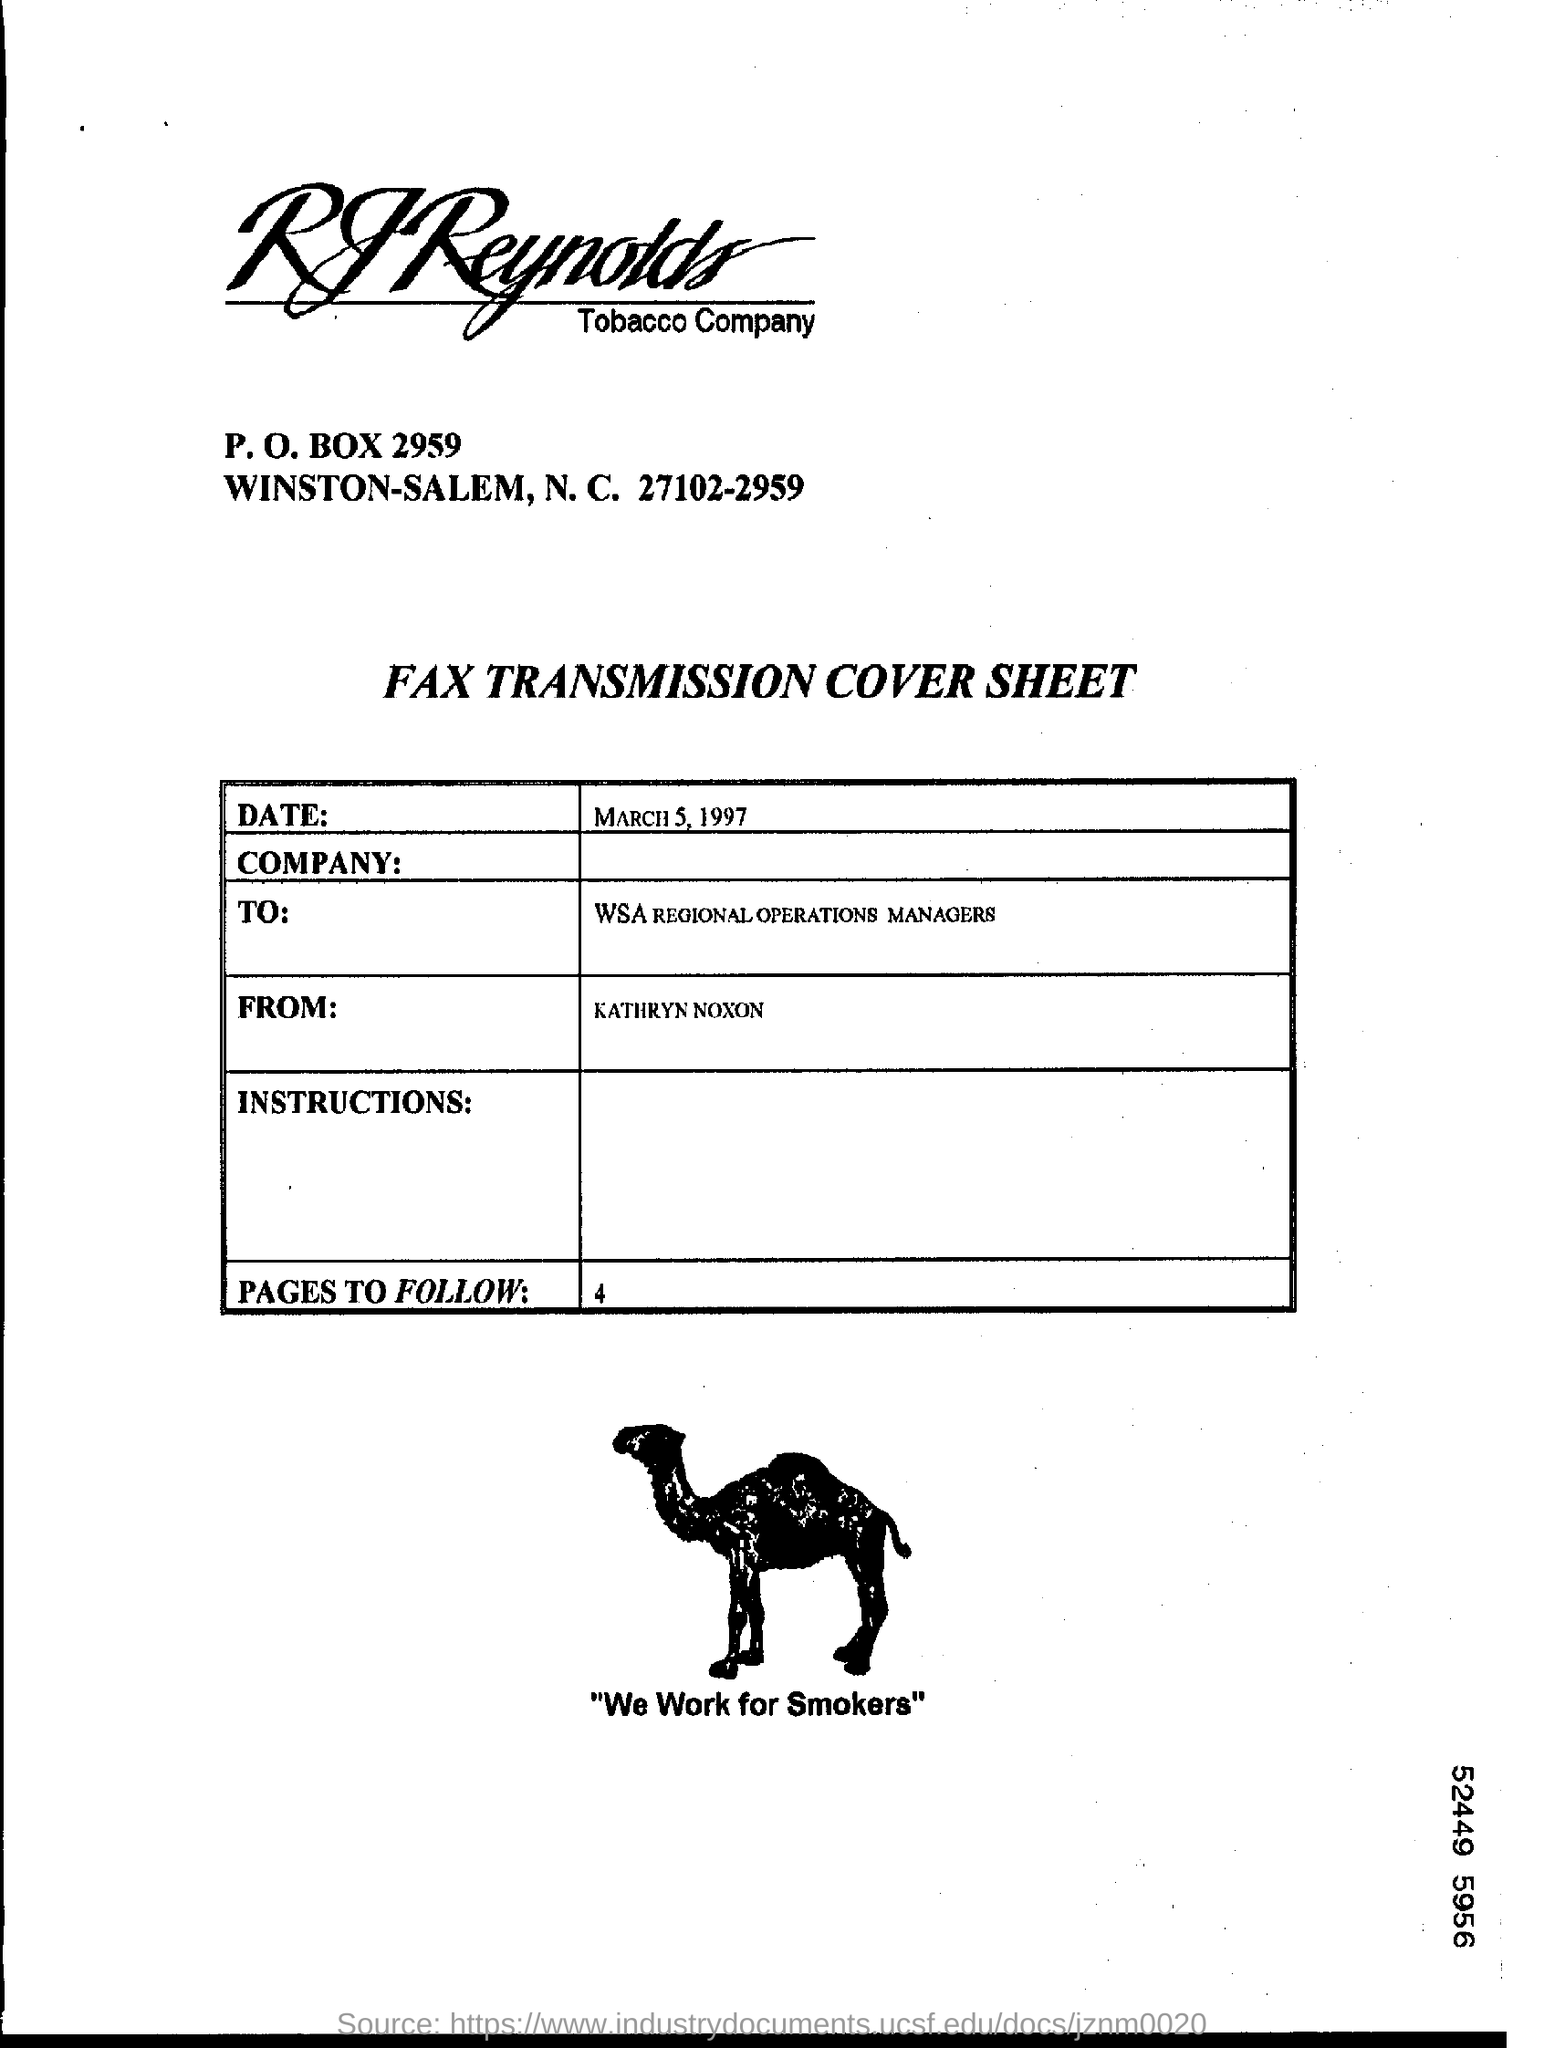List a handful of essential elements in this visual. The date mentioned on the cover sheet is March 5, 1997. The user is being asked if they want to follow 4 pages. The fax cover sheet is written to the WSA Regional Operations Managers. The author of this cover sheet is Kathryn Noxon. The sender of this fax is Kathryn Noxon. 